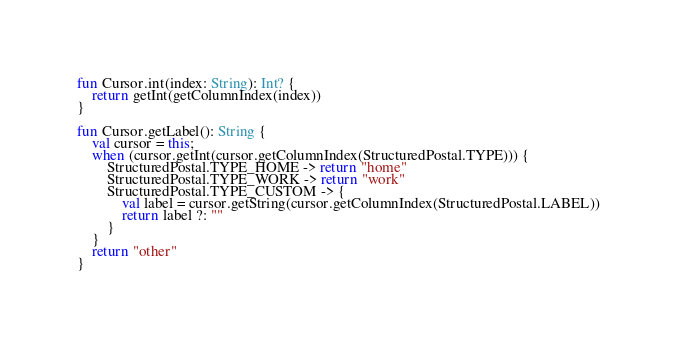Convert code to text. <code><loc_0><loc_0><loc_500><loc_500><_Kotlin_>
fun Cursor.int(index: String): Int? {
    return getInt(getColumnIndex(index))
}

fun Cursor.getLabel(): String {
    val cursor = this;
    when (cursor.getInt(cursor.getColumnIndex(StructuredPostal.TYPE))) {
        StructuredPostal.TYPE_HOME -> return "home"
        StructuredPostal.TYPE_WORK -> return "work"
        StructuredPostal.TYPE_CUSTOM -> {
            val label = cursor.getString(cursor.getColumnIndex(StructuredPostal.LABEL))
            return label ?: ""
        }
    }
    return "other"
}
</code> 